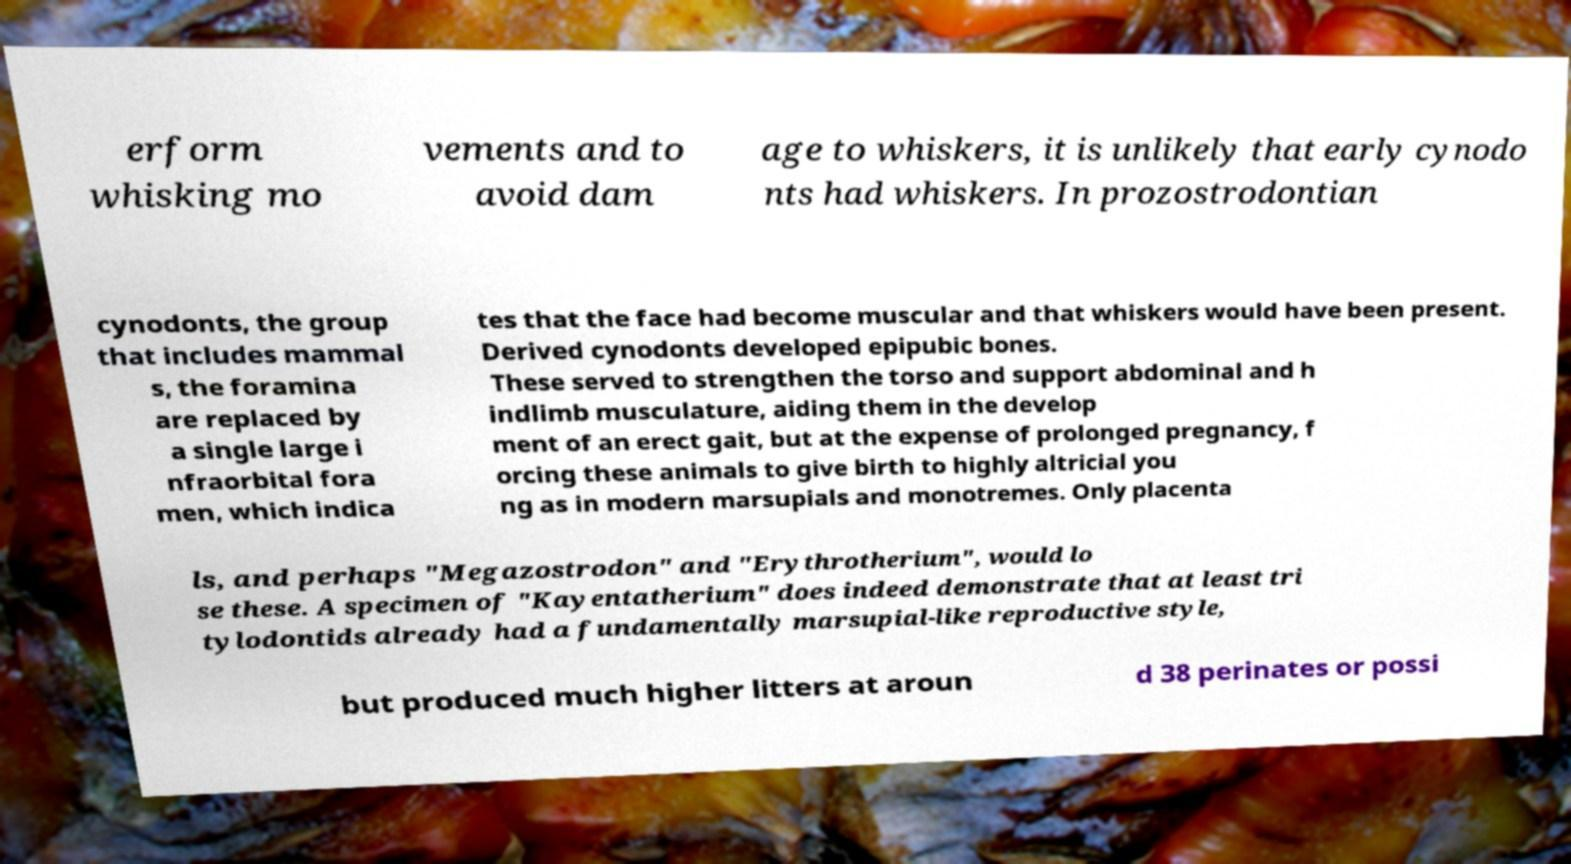Please read and relay the text visible in this image. What does it say? erform whisking mo vements and to avoid dam age to whiskers, it is unlikely that early cynodo nts had whiskers. In prozostrodontian cynodonts, the group that includes mammal s, the foramina are replaced by a single large i nfraorbital fora men, which indica tes that the face had become muscular and that whiskers would have been present. Derived cynodonts developed epipubic bones. These served to strengthen the torso and support abdominal and h indlimb musculature, aiding them in the develop ment of an erect gait, but at the expense of prolonged pregnancy, f orcing these animals to give birth to highly altricial you ng as in modern marsupials and monotremes. Only placenta ls, and perhaps "Megazostrodon" and "Erythrotherium", would lo se these. A specimen of "Kayentatherium" does indeed demonstrate that at least tri tylodontids already had a fundamentally marsupial-like reproductive style, but produced much higher litters at aroun d 38 perinates or possi 